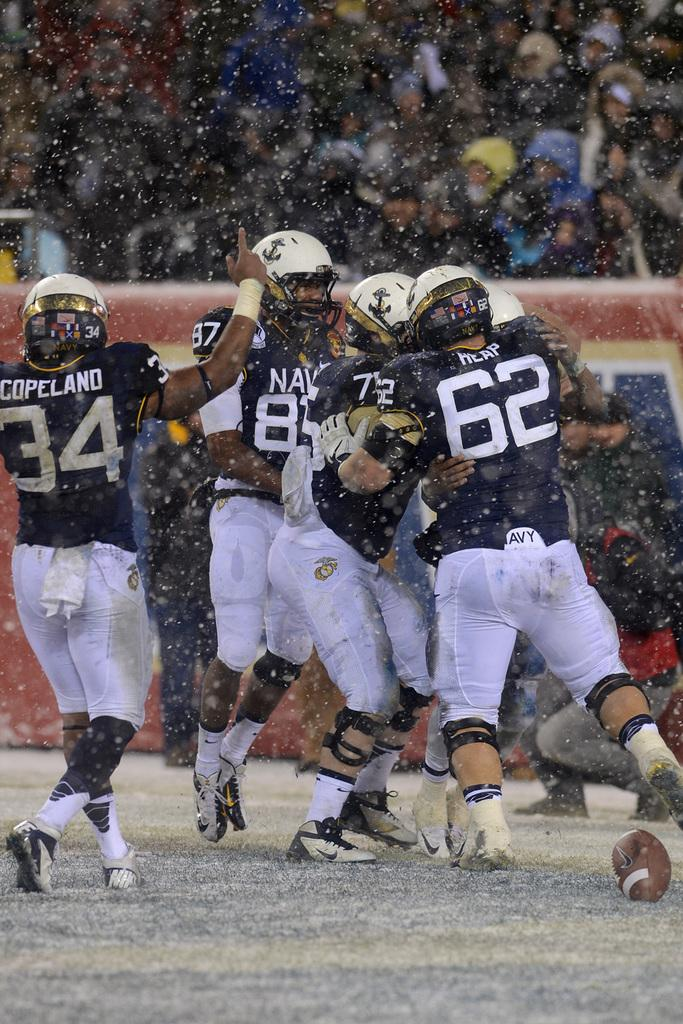How many people are present in the image? There are many people present on the ground in the image. What are the people wearing in the image? The people are wearing the same costume and helmets. What can be seen in the background of the image? There is a wall visible in the image. Are there people behind the wall? Yes, there are people present behind the wall. What type of trail can be seen in the image? There is no trail present in the image. 